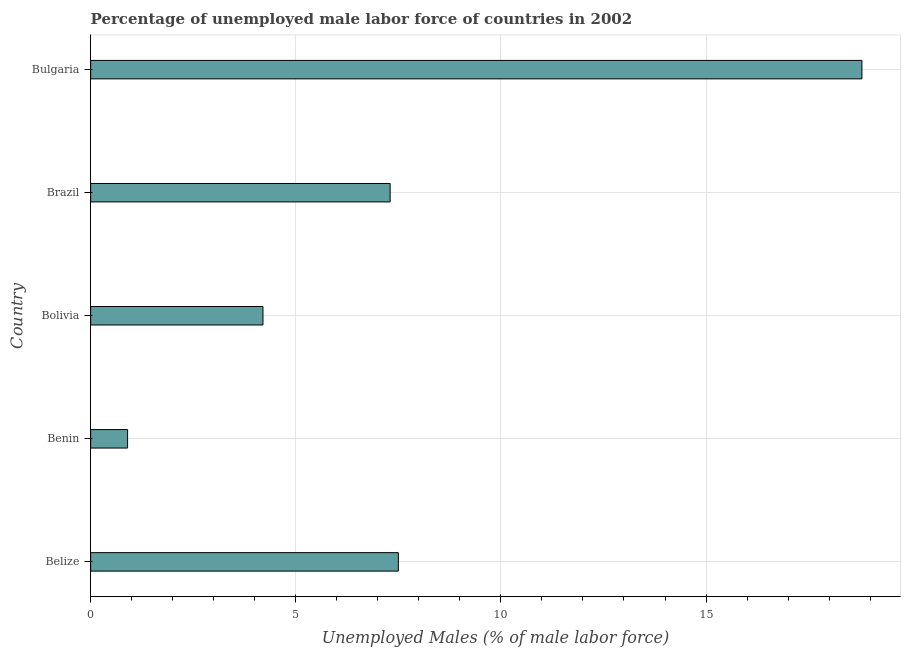Does the graph contain any zero values?
Provide a short and direct response. No. Does the graph contain grids?
Give a very brief answer. Yes. What is the title of the graph?
Offer a very short reply. Percentage of unemployed male labor force of countries in 2002. What is the label or title of the X-axis?
Make the answer very short. Unemployed Males (% of male labor force). What is the total unemployed male labour force in Bulgaria?
Offer a very short reply. 18.8. Across all countries, what is the maximum total unemployed male labour force?
Ensure brevity in your answer.  18.8. Across all countries, what is the minimum total unemployed male labour force?
Make the answer very short. 0.9. In which country was the total unemployed male labour force minimum?
Provide a short and direct response. Benin. What is the sum of the total unemployed male labour force?
Ensure brevity in your answer.  38.7. What is the average total unemployed male labour force per country?
Provide a succinct answer. 7.74. What is the median total unemployed male labour force?
Your answer should be very brief. 7.3. What is the ratio of the total unemployed male labour force in Bolivia to that in Bulgaria?
Your answer should be very brief. 0.22. Is the total unemployed male labour force in Benin less than that in Bolivia?
Your answer should be very brief. Yes. What is the difference between the highest and the second highest total unemployed male labour force?
Your answer should be very brief. 11.3. Is the sum of the total unemployed male labour force in Benin and Brazil greater than the maximum total unemployed male labour force across all countries?
Offer a terse response. No. What is the difference between the highest and the lowest total unemployed male labour force?
Your response must be concise. 17.9. How many bars are there?
Provide a succinct answer. 5. How many countries are there in the graph?
Provide a succinct answer. 5. What is the difference between two consecutive major ticks on the X-axis?
Give a very brief answer. 5. What is the Unemployed Males (% of male labor force) in Belize?
Your response must be concise. 7.5. What is the Unemployed Males (% of male labor force) of Benin?
Offer a very short reply. 0.9. What is the Unemployed Males (% of male labor force) in Bolivia?
Offer a very short reply. 4.2. What is the Unemployed Males (% of male labor force) of Brazil?
Your answer should be compact. 7.3. What is the Unemployed Males (% of male labor force) in Bulgaria?
Your response must be concise. 18.8. What is the difference between the Unemployed Males (% of male labor force) in Belize and Benin?
Give a very brief answer. 6.6. What is the difference between the Unemployed Males (% of male labor force) in Belize and Bolivia?
Ensure brevity in your answer.  3.3. What is the difference between the Unemployed Males (% of male labor force) in Belize and Brazil?
Offer a very short reply. 0.2. What is the difference between the Unemployed Males (% of male labor force) in Benin and Bulgaria?
Your answer should be very brief. -17.9. What is the difference between the Unemployed Males (% of male labor force) in Bolivia and Brazil?
Your answer should be compact. -3.1. What is the difference between the Unemployed Males (% of male labor force) in Bolivia and Bulgaria?
Provide a succinct answer. -14.6. What is the ratio of the Unemployed Males (% of male labor force) in Belize to that in Benin?
Ensure brevity in your answer.  8.33. What is the ratio of the Unemployed Males (% of male labor force) in Belize to that in Bolivia?
Make the answer very short. 1.79. What is the ratio of the Unemployed Males (% of male labor force) in Belize to that in Bulgaria?
Offer a very short reply. 0.4. What is the ratio of the Unemployed Males (% of male labor force) in Benin to that in Bolivia?
Give a very brief answer. 0.21. What is the ratio of the Unemployed Males (% of male labor force) in Benin to that in Brazil?
Ensure brevity in your answer.  0.12. What is the ratio of the Unemployed Males (% of male labor force) in Benin to that in Bulgaria?
Make the answer very short. 0.05. What is the ratio of the Unemployed Males (% of male labor force) in Bolivia to that in Brazil?
Ensure brevity in your answer.  0.57. What is the ratio of the Unemployed Males (% of male labor force) in Bolivia to that in Bulgaria?
Your answer should be compact. 0.22. What is the ratio of the Unemployed Males (% of male labor force) in Brazil to that in Bulgaria?
Provide a short and direct response. 0.39. 